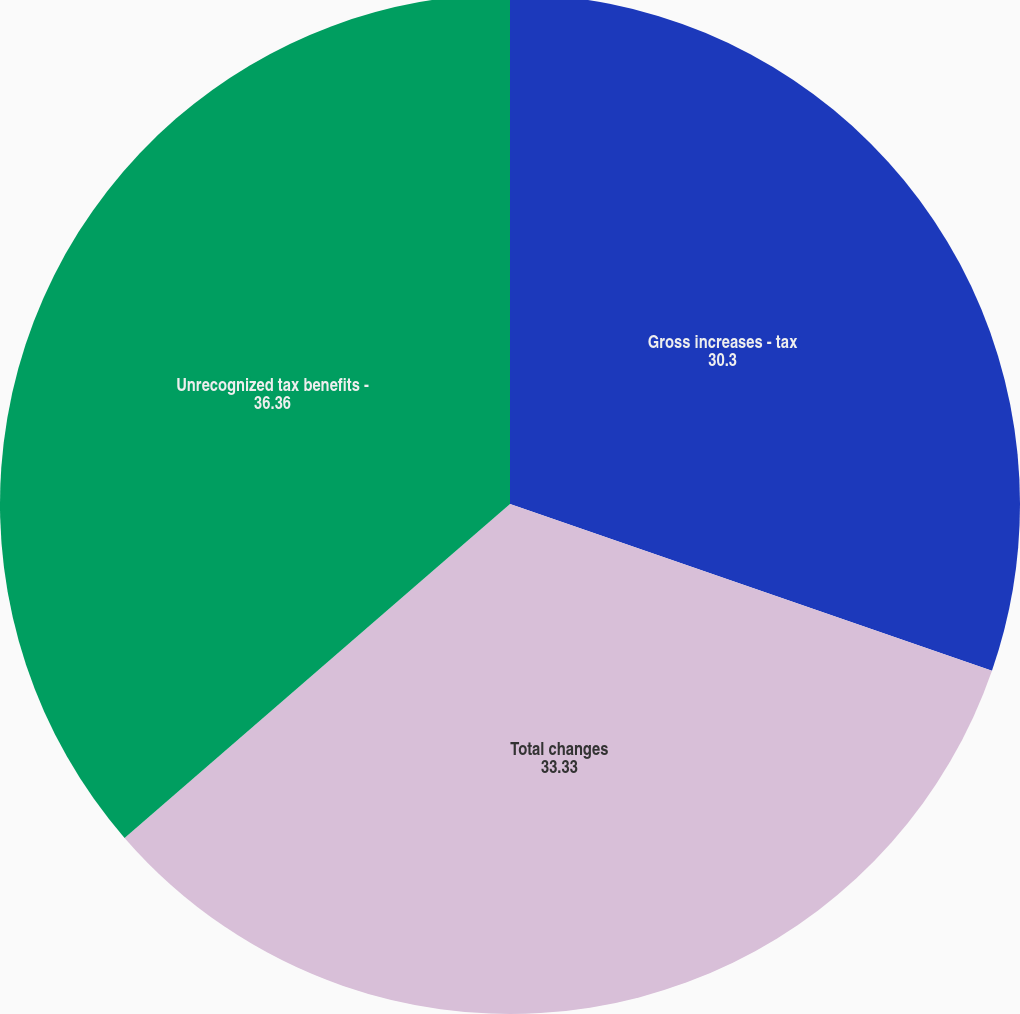<chart> <loc_0><loc_0><loc_500><loc_500><pie_chart><fcel>Gross increases - tax<fcel>Total changes<fcel>Unrecognized tax benefits -<nl><fcel>30.3%<fcel>33.33%<fcel>36.36%<nl></chart> 